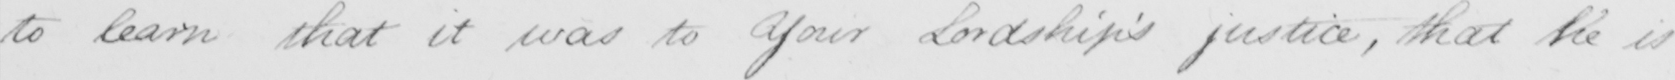Please transcribe the handwritten text in this image. to learn that it was to Your Lordship ' s justice , that he is 